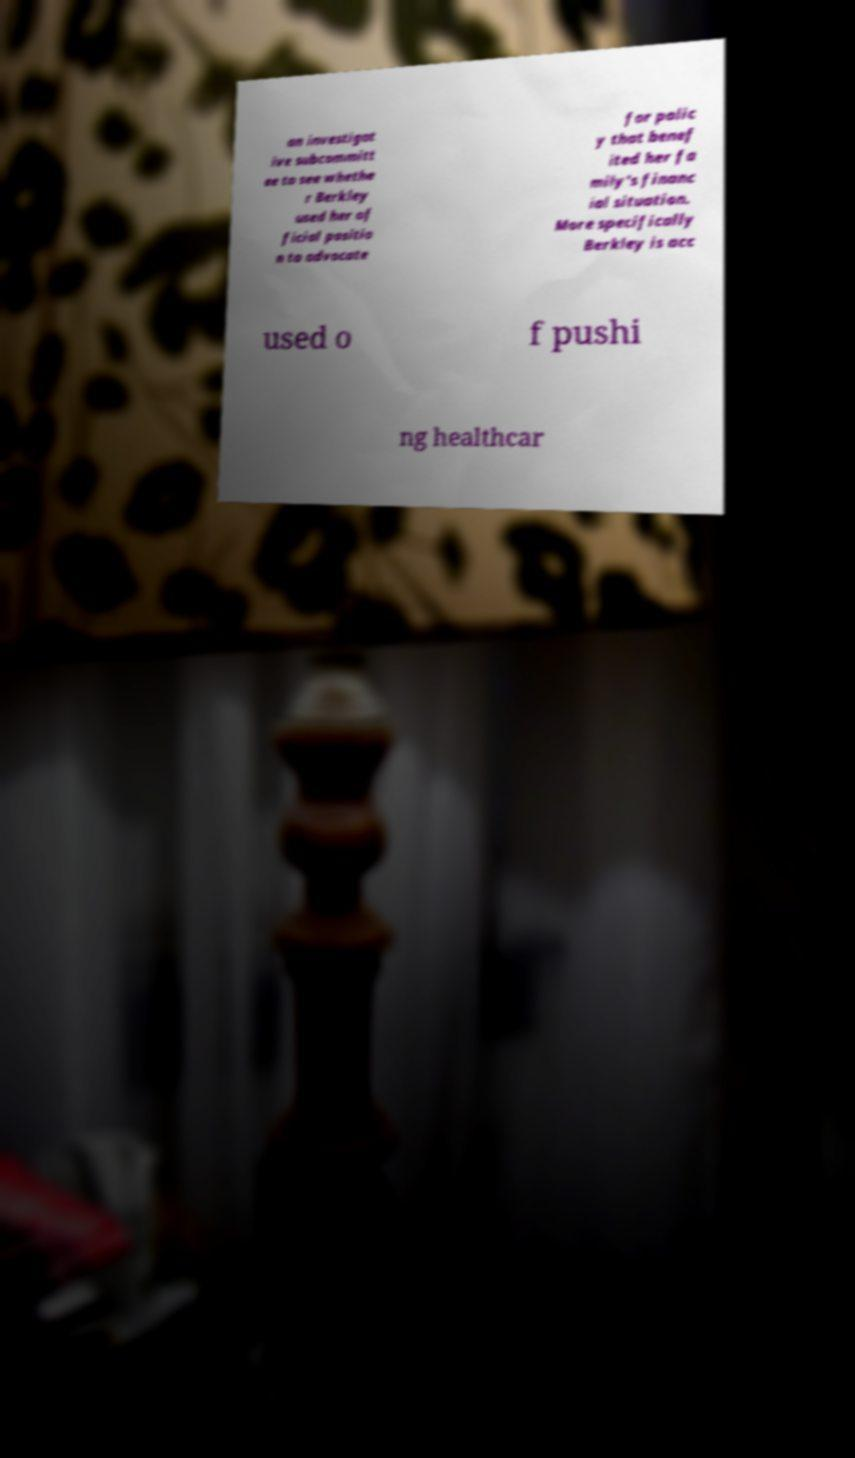I need the written content from this picture converted into text. Can you do that? an investigat ive subcommitt ee to see whethe r Berkley used her of ficial positio n to advocate for polic y that benef ited her fa mily's financ ial situation. More specifically Berkley is acc used o f pushi ng healthcar 